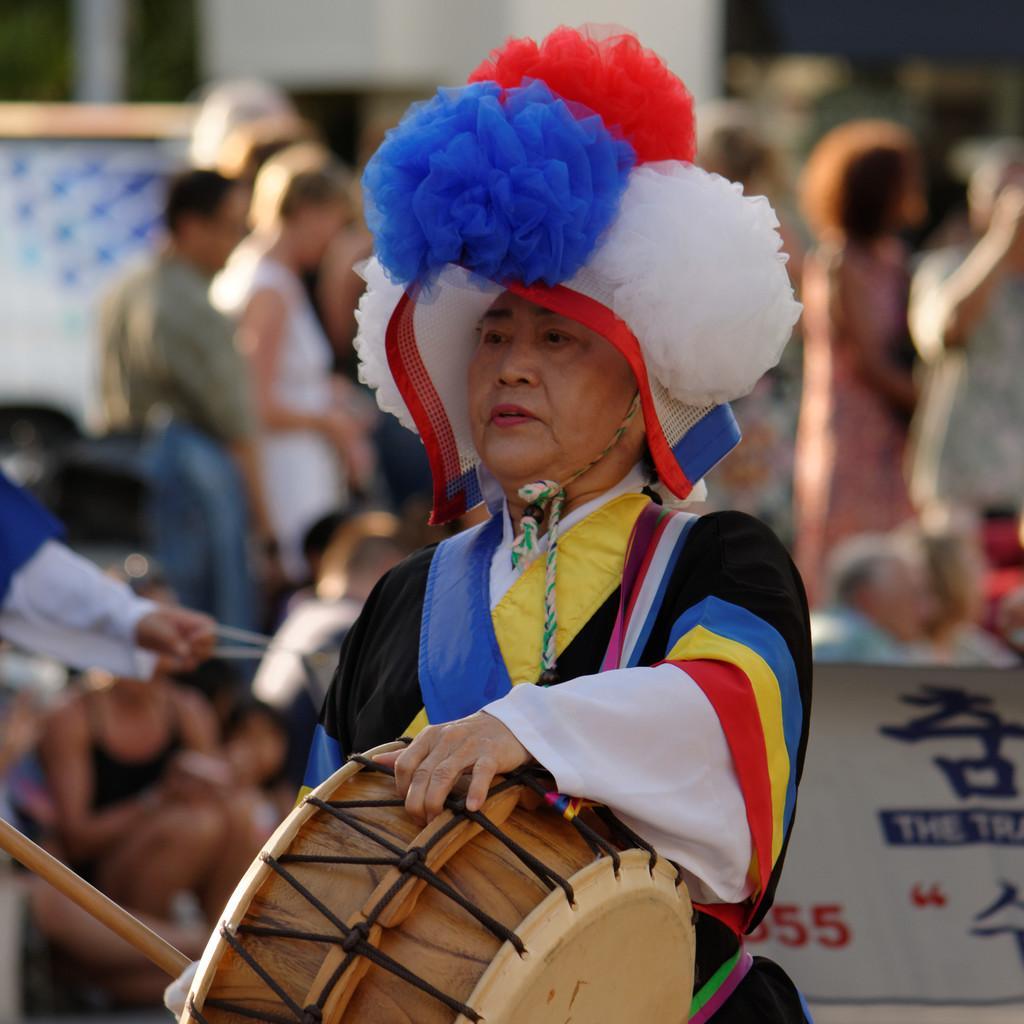Can you describe this image briefly? The picture is taken outside of the building where one woman is standing and wearing a costume and a big hat with colours and holding a drums and sticks in her hands, behind her there a people standing and sitting. 